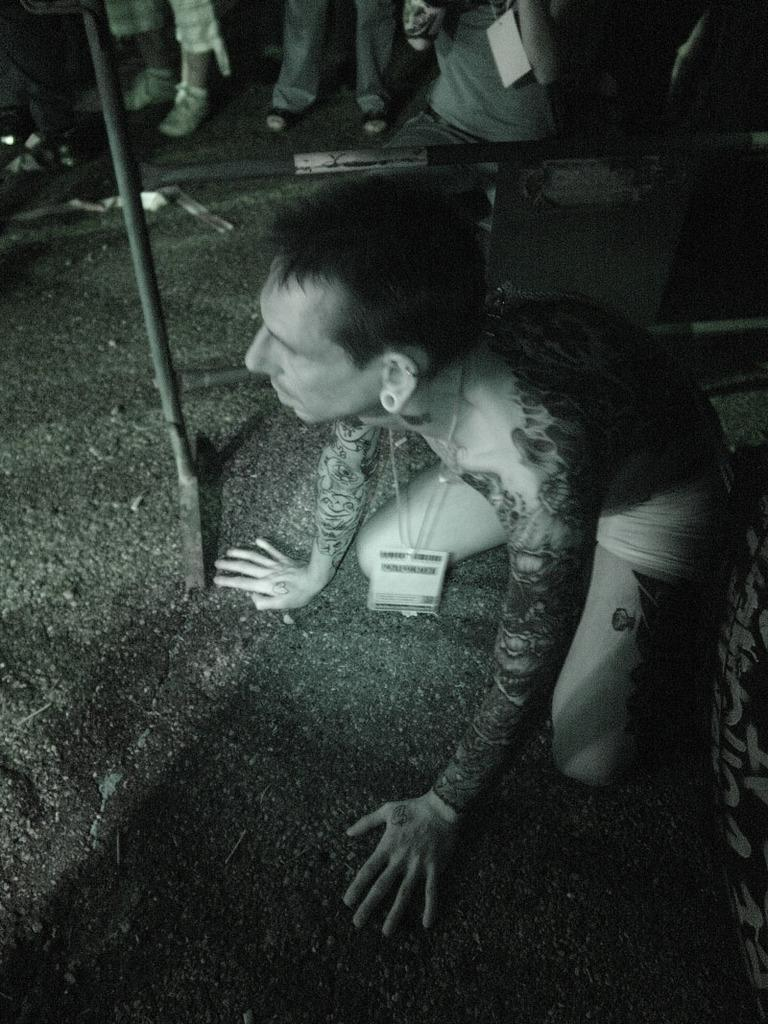What is the person in the image doing? The person in the image is in a squat position. What can be seen in the background of the image? There are iron rods in the background of the image. Are there any other people visible in the image? Yes, there is a group of persons in the background of the image. What type of order is being followed by the zinc in the image? There is no zinc present in the image, so it is not possible to determine if any order is being followed. 